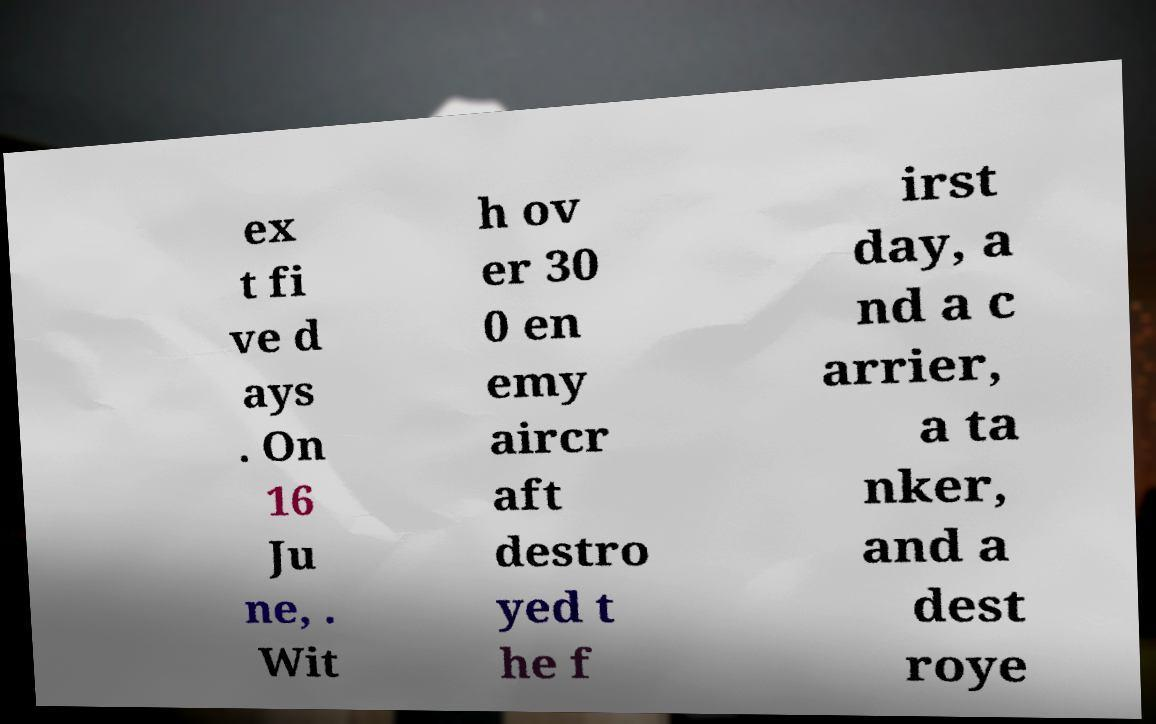Can you accurately transcribe the text from the provided image for me? ex t fi ve d ays . On 16 Ju ne, . Wit h ov er 30 0 en emy aircr aft destro yed t he f irst day, a nd a c arrier, a ta nker, and a dest roye 